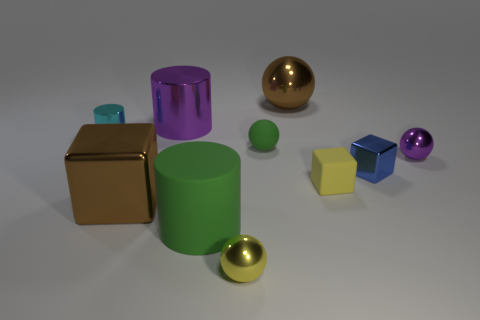Which object appears to be the largest? The green cylinder appears to be the largest object in terms of both height and volume when compared to the other objects present in the image. Can you provide the color of that object? The color of the largest object, the cylinder, is green. 